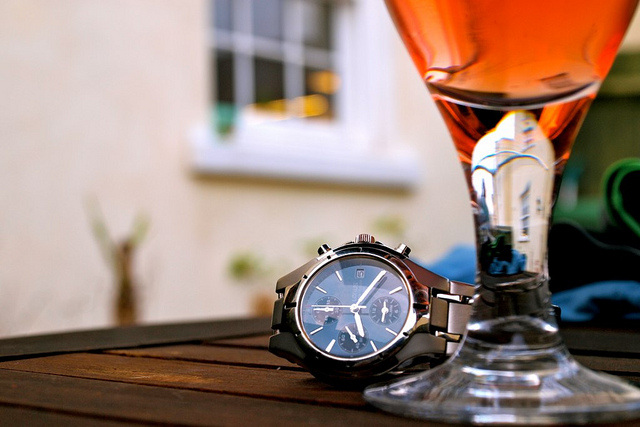<image>What time is it? It is unknown what time it is. It could be a variety of times including '8:20', '2:53', '5:05', '1:50', or '5:00'. What is the yellow object in the window? I am not sure what the yellow object in the window is. It could be a light, a lamp, or a reflection of light. What time is it? I am not sure what time it is. It can be seen '8:20', '2:53', '5:05', '1:50', '5:00' or '5:04'. What is the yellow object in the window? I don't know what the yellow object in the window is. It can be a light, a lamp or a reflection of light. 